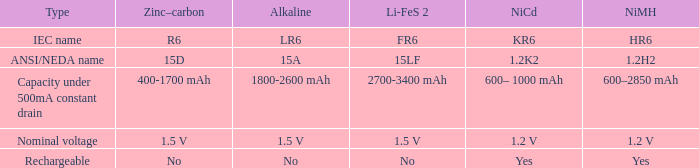What is NiCd, when Type is "Capacity under 500mA constant Drain"? 600– 1000 mAh. 